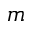Convert formula to latex. <formula><loc_0><loc_0><loc_500><loc_500>m</formula> 